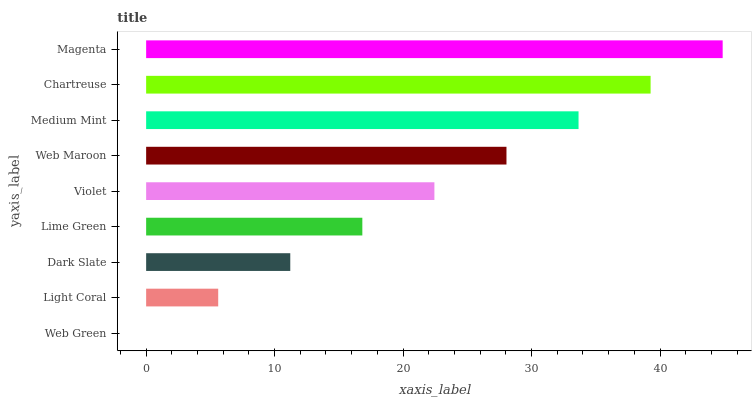Is Web Green the minimum?
Answer yes or no. Yes. Is Magenta the maximum?
Answer yes or no. Yes. Is Light Coral the minimum?
Answer yes or no. No. Is Light Coral the maximum?
Answer yes or no. No. Is Light Coral greater than Web Green?
Answer yes or no. Yes. Is Web Green less than Light Coral?
Answer yes or no. Yes. Is Web Green greater than Light Coral?
Answer yes or no. No. Is Light Coral less than Web Green?
Answer yes or no. No. Is Violet the high median?
Answer yes or no. Yes. Is Violet the low median?
Answer yes or no. Yes. Is Web Green the high median?
Answer yes or no. No. Is Medium Mint the low median?
Answer yes or no. No. 